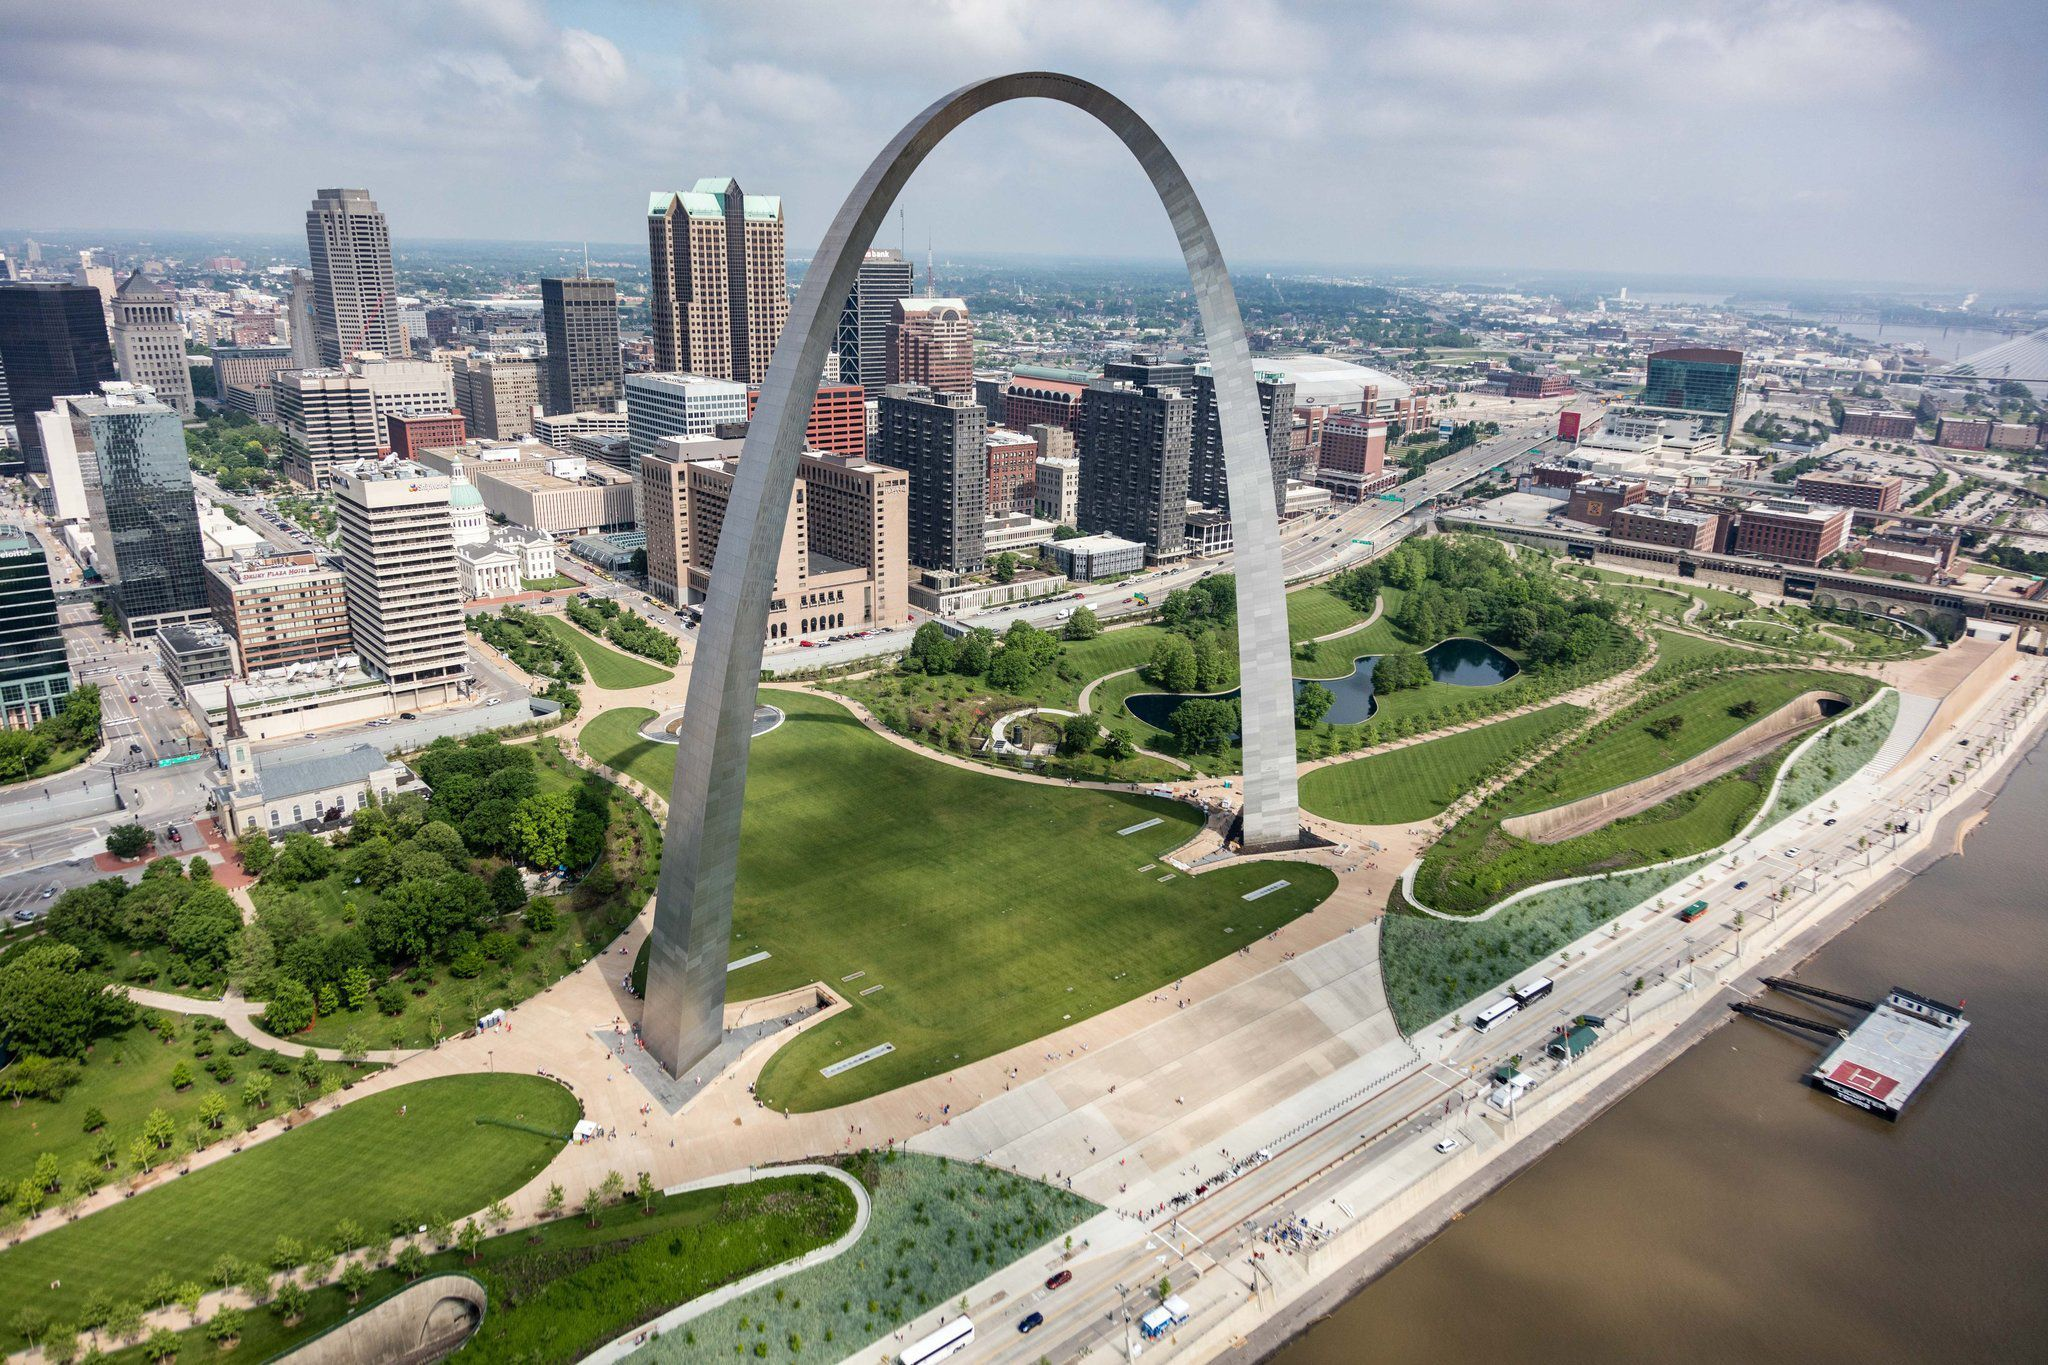What are some unique features or lesser-known facts about the Gateway Arch? Some unique features of the Gateway Arch include its stainless steel construction, which gives it a sleek and modern appearance. The arch's design, conceived by architect Eero Saarinen, is based on an inverted weighted catenary curve, a shape mathematically deemed as the most structurally efficient for an arch. A lesser-known fact is that the arch's height and width are both exactly 630 feet, making it the tallest man-made monument in the United States. Additionally, visitors can ride a tram to the top of the arch, where they can enjoy panoramic views of St. Louis and the Mississippi River. Another interesting tidbit is that the arch was built to sway up to 18 inches in high winds but typically moves no more than half an inch. If the Gateway Arch could speak, what stories would it tell about St. Louis? If the Gateway Arch could speak, it would narrate tales of the dreams and challenges of early American pioneers who embarked westward from St. Louis, seeking new opportunities and forging the path for the country's expansion. It would recount the journey of its own creation, a story of ambitious vision and modern engineering, aimed at celebrating the city’s historical significance. The arch would voice the vibrant echoes of countless visitors who have stood beneath its towering structure, admiring its beauty and reflecting on the city’s storied past. It would speak of the Mississippi River’s enduring presence, witnessing the changing tides of commerce, culture, and community life that have shaped St. Louis through the decades. The Gateway Arch, with its commanding view, would tell tales of resilience, innovation, and the continuous march of progress that defines the city's spirit. 